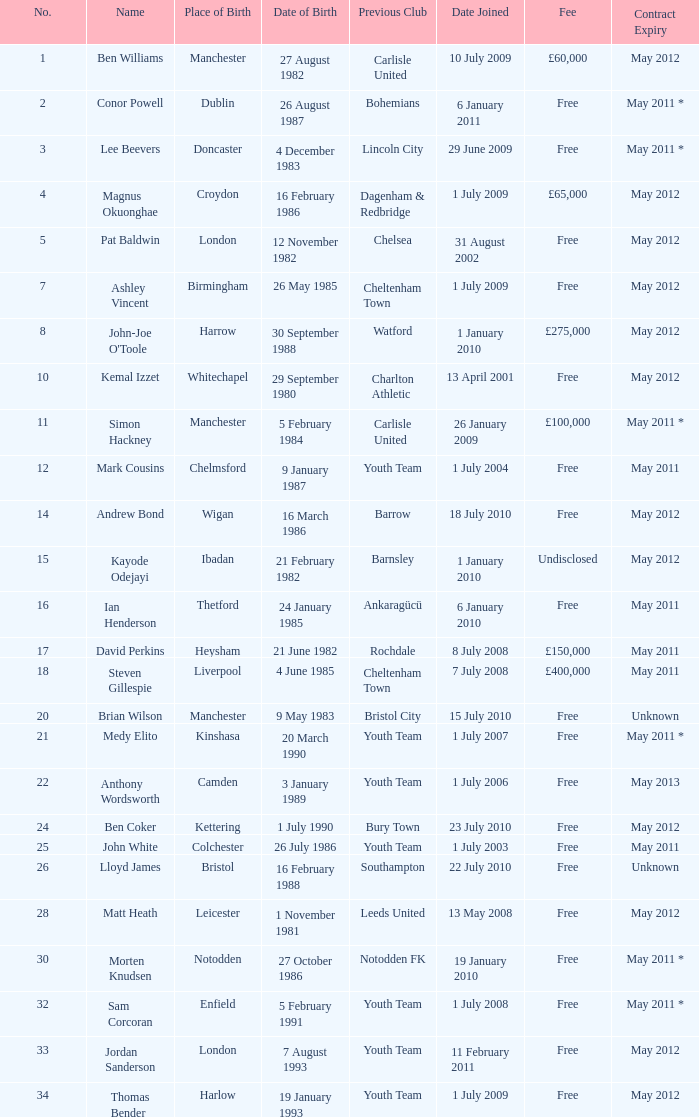What is the fee for ankaragücü previous club Free. 